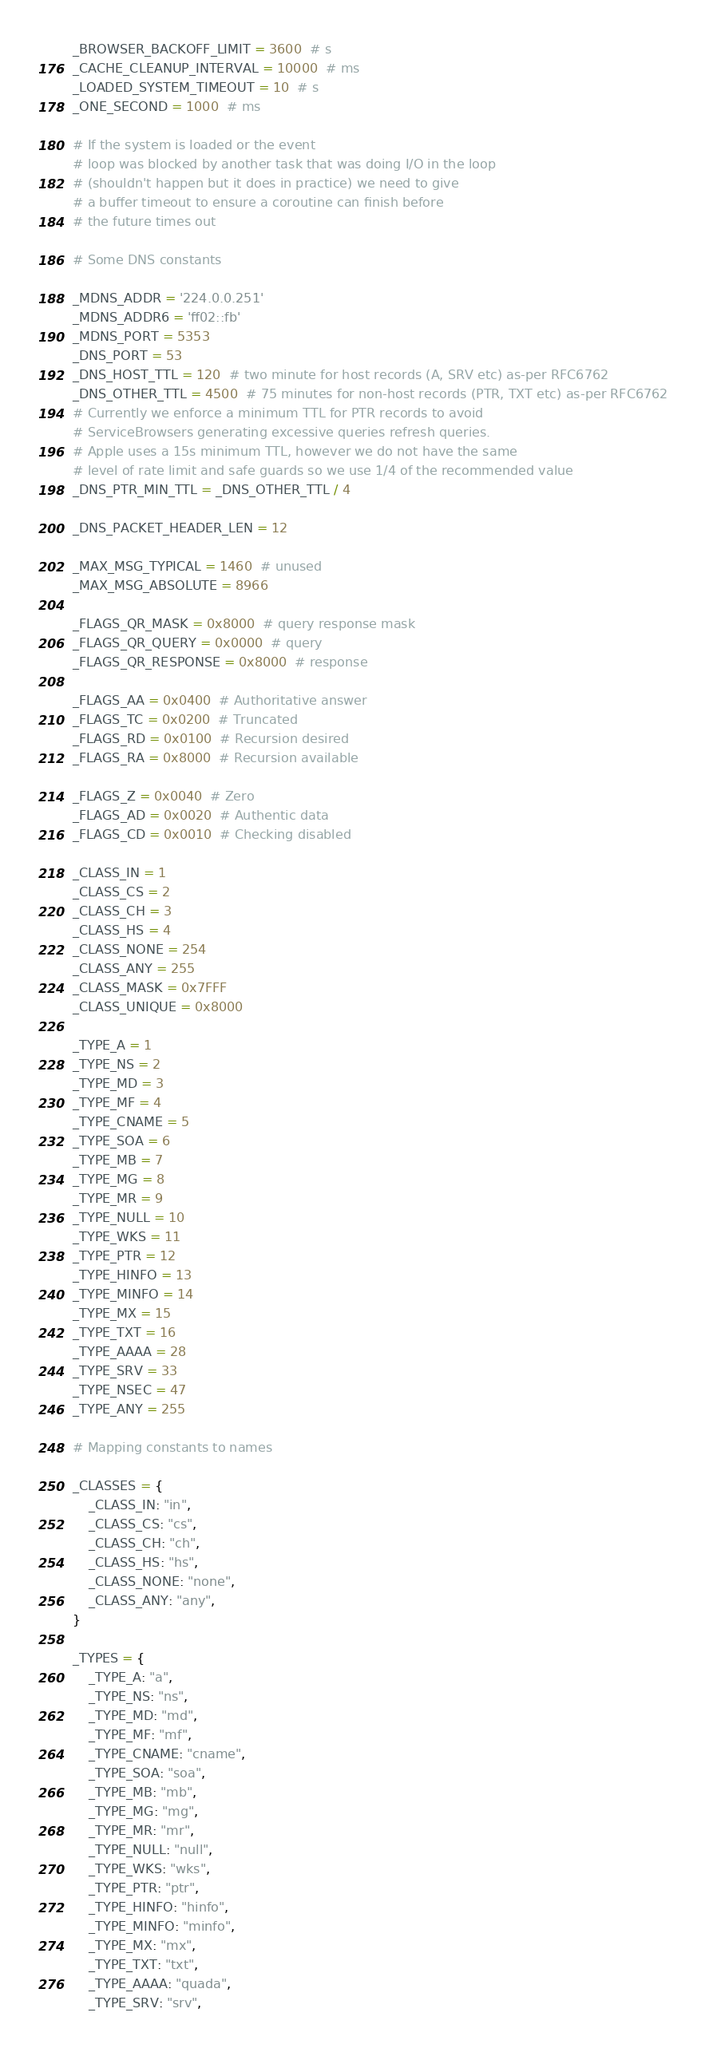Convert code to text. <code><loc_0><loc_0><loc_500><loc_500><_Python_>_BROWSER_BACKOFF_LIMIT = 3600  # s
_CACHE_CLEANUP_INTERVAL = 10000  # ms
_LOADED_SYSTEM_TIMEOUT = 10  # s
_ONE_SECOND = 1000  # ms

# If the system is loaded or the event
# loop was blocked by another task that was doing I/O in the loop
# (shouldn't happen but it does in practice) we need to give
# a buffer timeout to ensure a coroutine can finish before
# the future times out

# Some DNS constants

_MDNS_ADDR = '224.0.0.251'
_MDNS_ADDR6 = 'ff02::fb'
_MDNS_PORT = 5353
_DNS_PORT = 53
_DNS_HOST_TTL = 120  # two minute for host records (A, SRV etc) as-per RFC6762
_DNS_OTHER_TTL = 4500  # 75 minutes for non-host records (PTR, TXT etc) as-per RFC6762
# Currently we enforce a minimum TTL for PTR records to avoid
# ServiceBrowsers generating excessive queries refresh queries.
# Apple uses a 15s minimum TTL, however we do not have the same
# level of rate limit and safe guards so we use 1/4 of the recommended value
_DNS_PTR_MIN_TTL = _DNS_OTHER_TTL / 4

_DNS_PACKET_HEADER_LEN = 12

_MAX_MSG_TYPICAL = 1460  # unused
_MAX_MSG_ABSOLUTE = 8966

_FLAGS_QR_MASK = 0x8000  # query response mask
_FLAGS_QR_QUERY = 0x0000  # query
_FLAGS_QR_RESPONSE = 0x8000  # response

_FLAGS_AA = 0x0400  # Authoritative answer
_FLAGS_TC = 0x0200  # Truncated
_FLAGS_RD = 0x0100  # Recursion desired
_FLAGS_RA = 0x8000  # Recursion available

_FLAGS_Z = 0x0040  # Zero
_FLAGS_AD = 0x0020  # Authentic data
_FLAGS_CD = 0x0010  # Checking disabled

_CLASS_IN = 1
_CLASS_CS = 2
_CLASS_CH = 3
_CLASS_HS = 4
_CLASS_NONE = 254
_CLASS_ANY = 255
_CLASS_MASK = 0x7FFF
_CLASS_UNIQUE = 0x8000

_TYPE_A = 1
_TYPE_NS = 2
_TYPE_MD = 3
_TYPE_MF = 4
_TYPE_CNAME = 5
_TYPE_SOA = 6
_TYPE_MB = 7
_TYPE_MG = 8
_TYPE_MR = 9
_TYPE_NULL = 10
_TYPE_WKS = 11
_TYPE_PTR = 12
_TYPE_HINFO = 13
_TYPE_MINFO = 14
_TYPE_MX = 15
_TYPE_TXT = 16
_TYPE_AAAA = 28
_TYPE_SRV = 33
_TYPE_NSEC = 47
_TYPE_ANY = 255

# Mapping constants to names

_CLASSES = {
    _CLASS_IN: "in",
    _CLASS_CS: "cs",
    _CLASS_CH: "ch",
    _CLASS_HS: "hs",
    _CLASS_NONE: "none",
    _CLASS_ANY: "any",
}

_TYPES = {
    _TYPE_A: "a",
    _TYPE_NS: "ns",
    _TYPE_MD: "md",
    _TYPE_MF: "mf",
    _TYPE_CNAME: "cname",
    _TYPE_SOA: "soa",
    _TYPE_MB: "mb",
    _TYPE_MG: "mg",
    _TYPE_MR: "mr",
    _TYPE_NULL: "null",
    _TYPE_WKS: "wks",
    _TYPE_PTR: "ptr",
    _TYPE_HINFO: "hinfo",
    _TYPE_MINFO: "minfo",
    _TYPE_MX: "mx",
    _TYPE_TXT: "txt",
    _TYPE_AAAA: "quada",
    _TYPE_SRV: "srv",</code> 